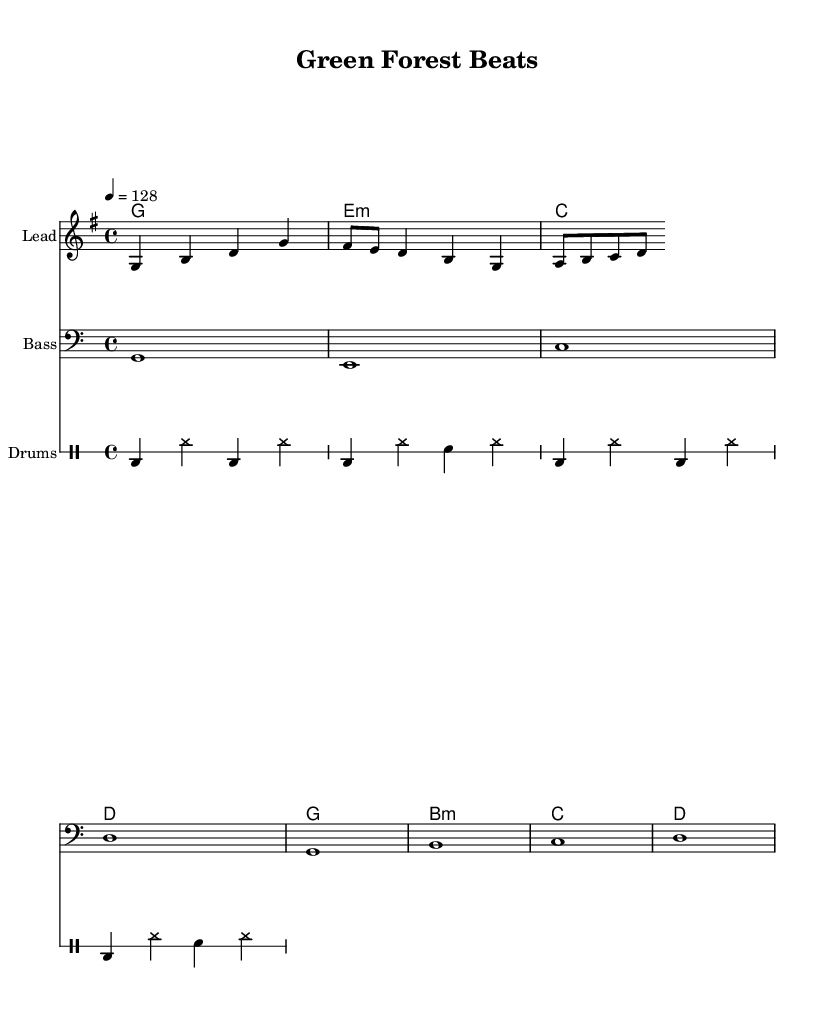What is the key signature of this music? The key signature is G major, which has one sharp (F#). This can be identified from the presence of the F# note in the melody and harmonies.
Answer: G major What is the time signature of this piece? The time signature is 4/4, which indicates four beats per measure. This is evident as each measure contains four quarter-note beats, consistent throughout the piece.
Answer: 4/4 What is the tempo marking for this score? The tempo marking is 128 beats per minute, indicated by the tempo notation "4 = 128" at the beginning of the score. This means the quarter note gets 128 beats per minute.
Answer: 128 How many measures are in the melody? There are four measures in the melody section. This can be counted by observing the vertical bar lines that separate each measure in the melody staff.
Answer: 4 Which instruments are featured in this score? The score features three instruments: Lead, Bass, and Drums. These instruments are labeled at the beginning of each staff indicated in the score.
Answer: Lead, Bass, Drums What type of scale is used predominantly in the lead melody? The scale used predominantly in the lead melody is the G major scale, as the melody consists primarily of notes from this scale (G, A, B, C, D, E, F#).
Answer: G major scale 